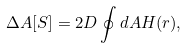Convert formula to latex. <formula><loc_0><loc_0><loc_500><loc_500>\Delta A [ S ] = 2 D \oint d A H ( { r } ) ,</formula> 